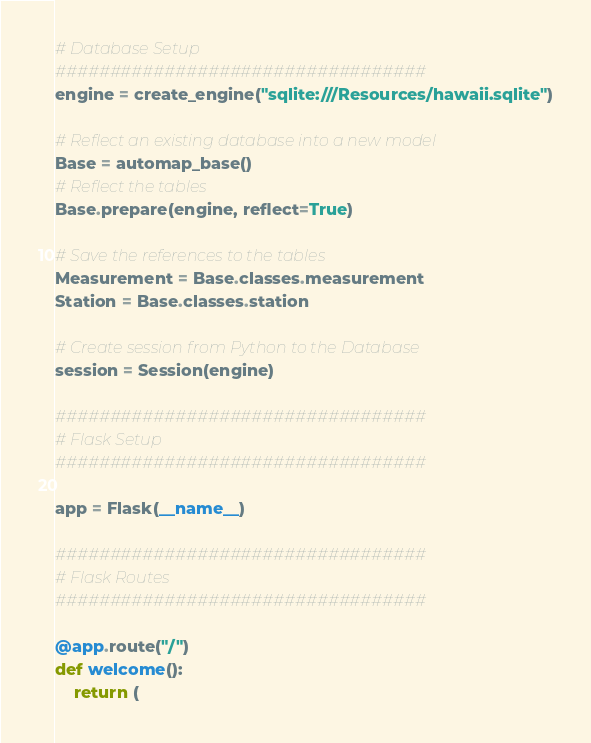Convert code to text. <code><loc_0><loc_0><loc_500><loc_500><_Python_># Database Setup
##################################
engine = create_engine("sqlite:///Resources/hawaii.sqlite")

# Reflect an existing database into a new model
Base = automap_base()
# Reflect the tables
Base.prepare(engine, reflect=True)

# Save the references to the tables
Measurement = Base.classes.measurement
Station = Base.classes.station

# Create session from Python to the Database
session = Session(engine)

##################################
# Flask Setup
##################################

app = Flask(__name__)

##################################
# Flask Routes
##################################

@app.route("/")
def welcome():
    return (</code> 